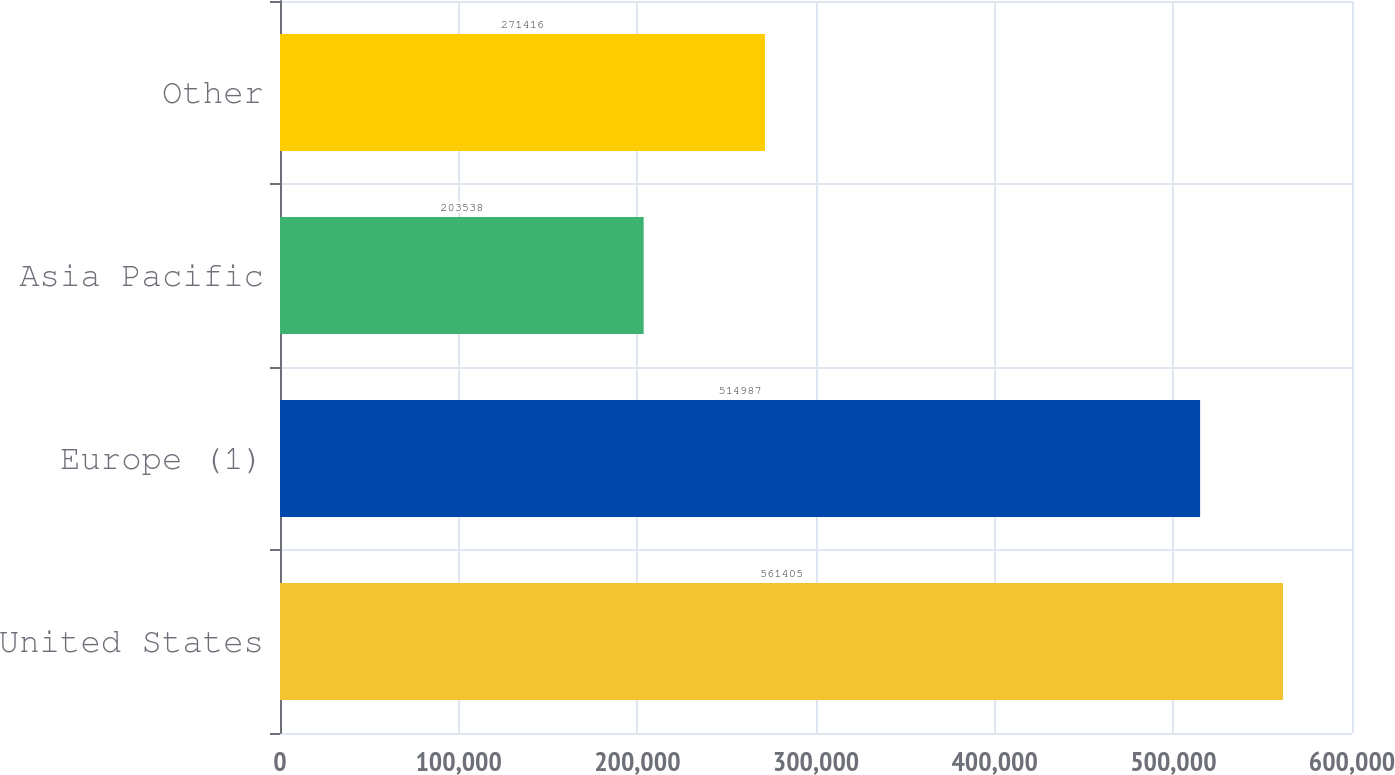<chart> <loc_0><loc_0><loc_500><loc_500><bar_chart><fcel>United States<fcel>Europe (1)<fcel>Asia Pacific<fcel>Other<nl><fcel>561405<fcel>514987<fcel>203538<fcel>271416<nl></chart> 